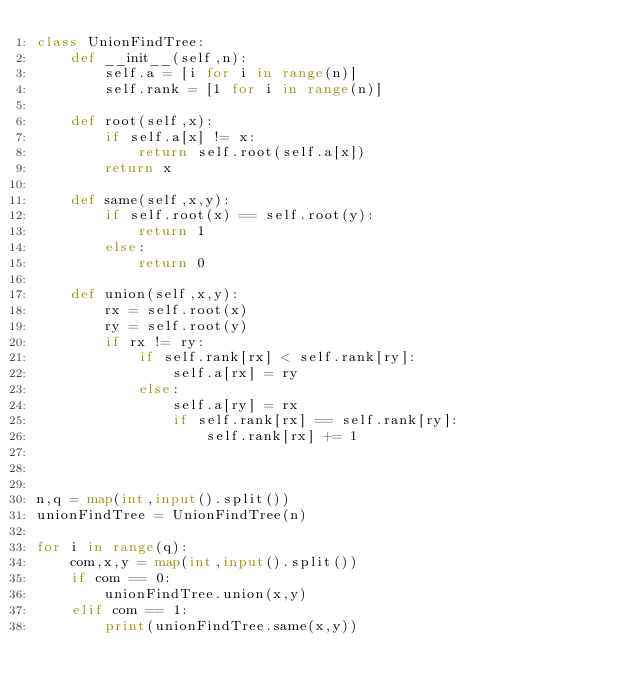<code> <loc_0><loc_0><loc_500><loc_500><_Python_>class UnionFindTree:    
    def __init__(self,n):
        self.a = [i for i in range(n)]
        self.rank = [1 for i in range(n)]

    def root(self,x):
        if self.a[x] != x:
            return self.root(self.a[x])
        return x

    def same(self,x,y):
        if self.root(x) == self.root(y):
            return 1
        else:
            return 0

    def union(self,x,y):
        rx = self.root(x)
        ry = self.root(y)
        if rx != ry:
            if self.rank[rx] < self.rank[ry]:
                self.a[rx] = ry
            else:
                self.a[ry] = rx
                if self.rank[rx] == self.rank[ry]:
                    self.rank[rx] += 1
            
                

n,q = map(int,input().split())
unionFindTree = UnionFindTree(n)

for i in range(q):
    com,x,y = map(int,input().split())
    if com == 0:
        unionFindTree.union(x,y)
    elif com == 1:
        print(unionFindTree.same(x,y))

</code> 